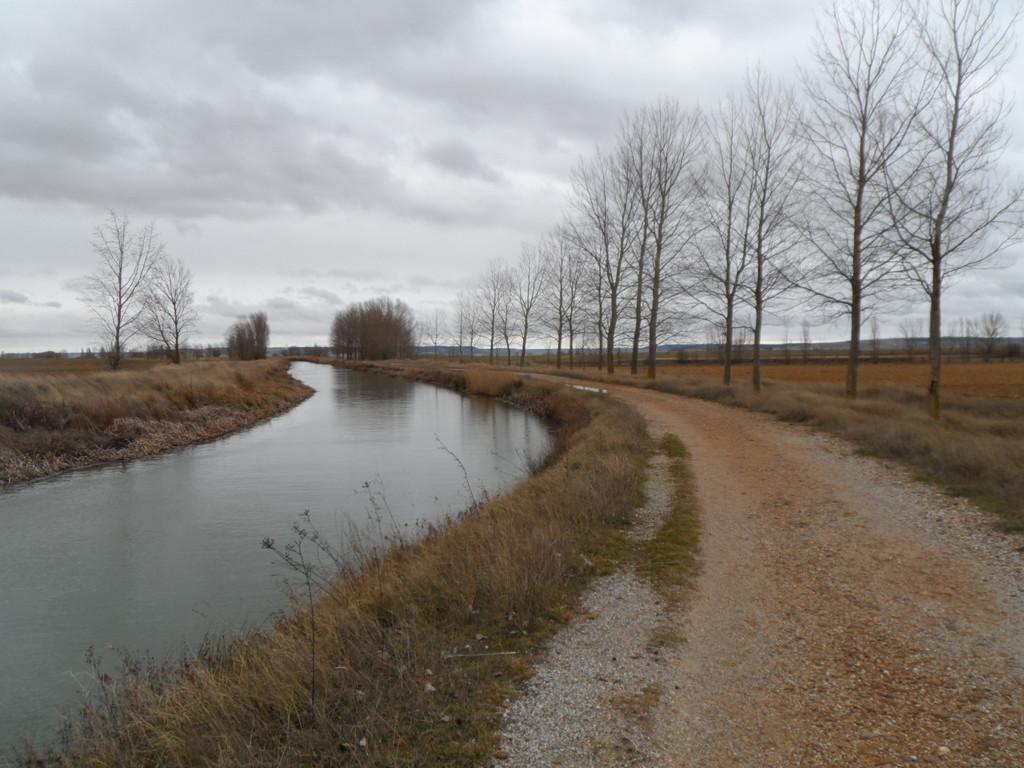Where was the picture taken? The picture was clicked outside the city. What can be seen on the left side of the image? There is a water body on the left side of the image. What type of vegetation is visible in the image? Grass is visible in the image. What is visible in the background of the image? There is a sky, trees, and plants visible in the background of the image. What theory is being debated in the image? There is no theory or debate present in the image; it features a natural scene with a water body, grass, and trees in the background. 